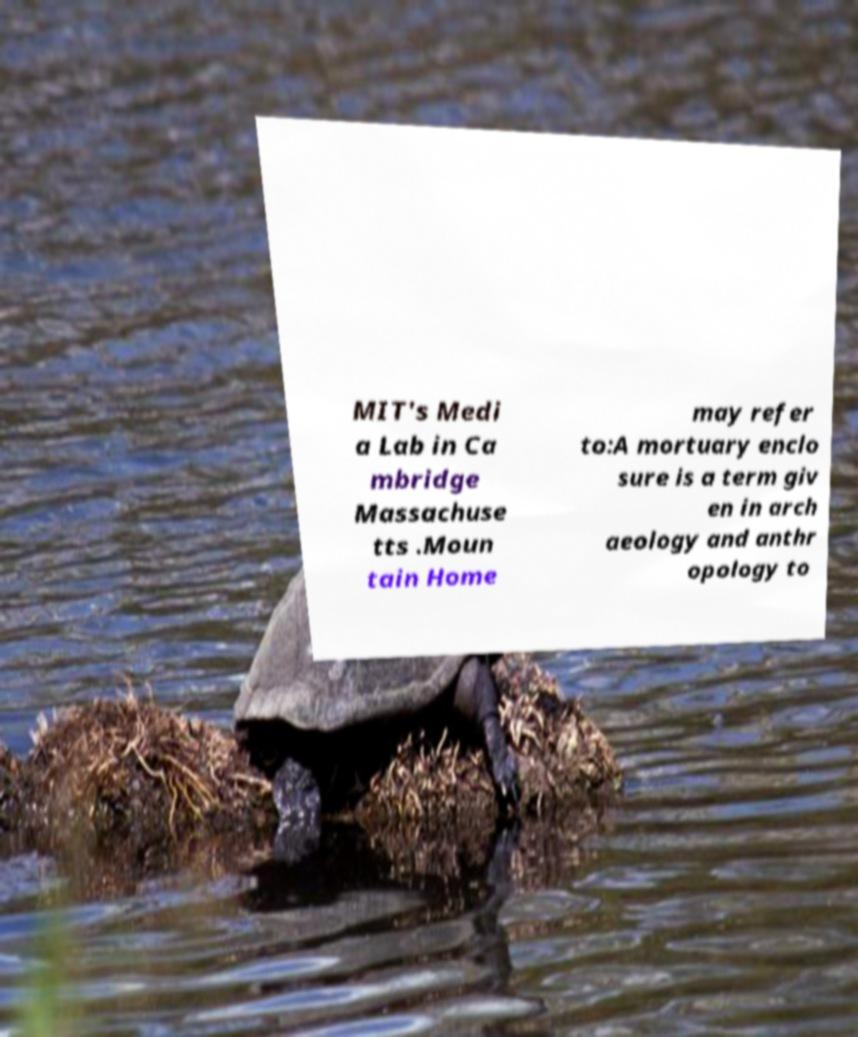Please read and relay the text visible in this image. What does it say? MIT's Medi a Lab in Ca mbridge Massachuse tts .Moun tain Home may refer to:A mortuary enclo sure is a term giv en in arch aeology and anthr opology to 